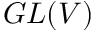Convert formula to latex. <formula><loc_0><loc_0><loc_500><loc_500>G L ( V )</formula> 